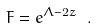<formula> <loc_0><loc_0><loc_500><loc_500>F = e ^ { \Lambda - 2 z } \ .</formula> 